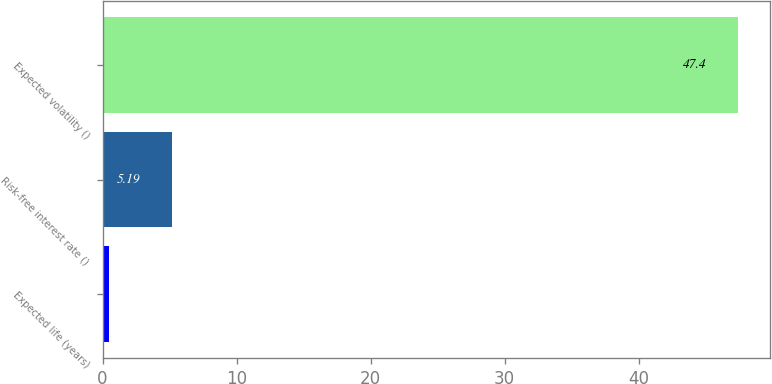Convert chart. <chart><loc_0><loc_0><loc_500><loc_500><bar_chart><fcel>Expected life (years)<fcel>Risk-free interest rate ()<fcel>Expected volatility ()<nl><fcel>0.5<fcel>5.19<fcel>47.4<nl></chart> 